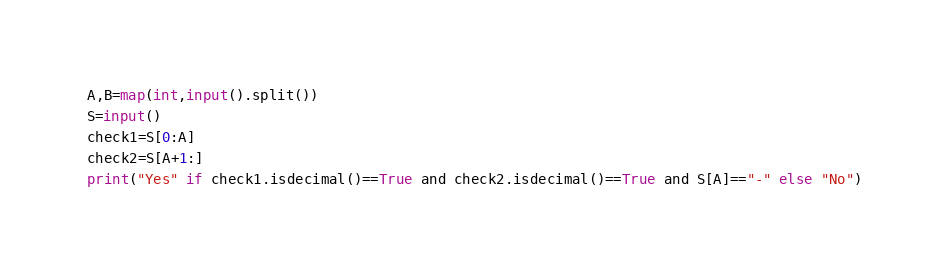Convert code to text. <code><loc_0><loc_0><loc_500><loc_500><_Python_>A,B=map(int,input().split())
S=input()
check1=S[0:A]
check2=S[A+1:]
print("Yes" if check1.isdecimal()==True and check2.isdecimal()==True and S[A]=="-" else "No")
</code> 